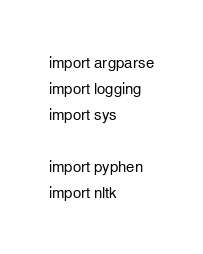Convert code to text. <code><loc_0><loc_0><loc_500><loc_500><_Python_>import argparse
import logging
import sys

import pyphen
import nltk
</code> 